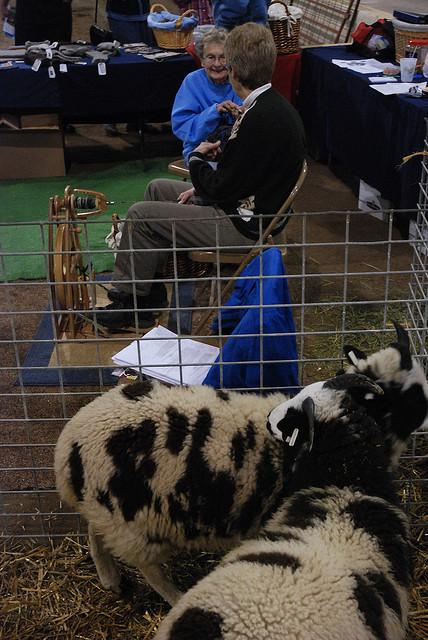How many spots on the cow?
Give a very brief answer. 0. Are those real cows?
Answer briefly. No. Is this a wooden fence?
Keep it brief. No. Are the cows all the same size?
Keep it brief. Yes. Is she riding a pony?
Short answer required. No. Are they indoors?
Short answer required. No. Is the item the man has his foot on modern or antique?
Short answer required. Antique. Which cow is older?
Quick response, please. Left. 